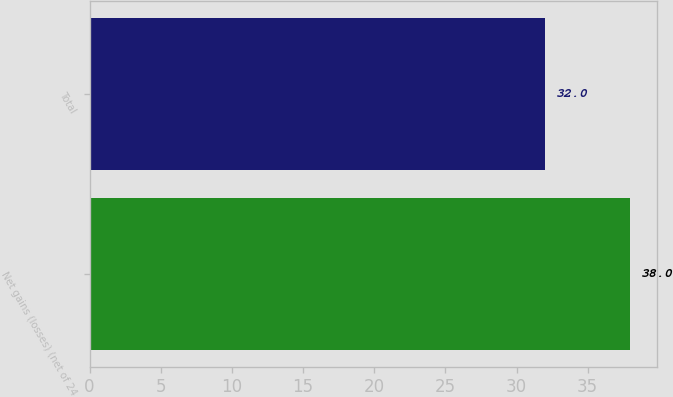Convert chart to OTSL. <chart><loc_0><loc_0><loc_500><loc_500><bar_chart><fcel>Net gains (losses) (net of 24<fcel>Total<nl><fcel>38<fcel>32<nl></chart> 